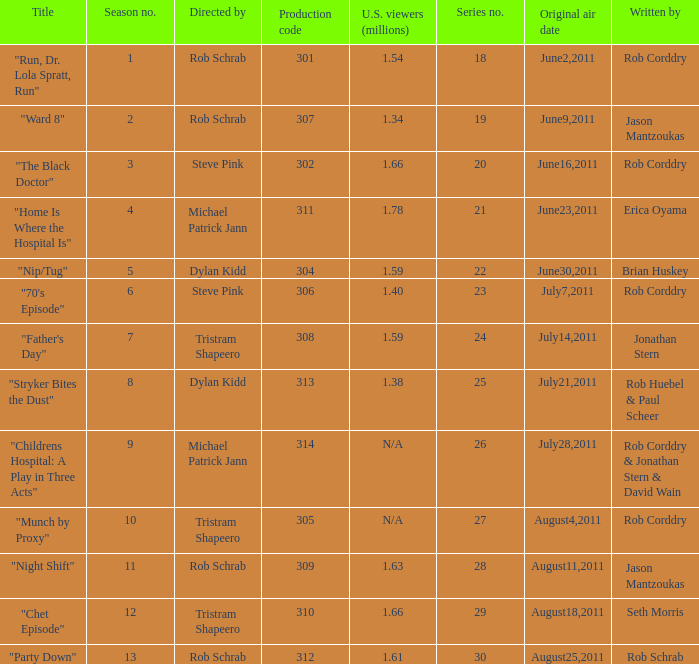At most what number in the series was the episode "chet episode"? 29.0. 